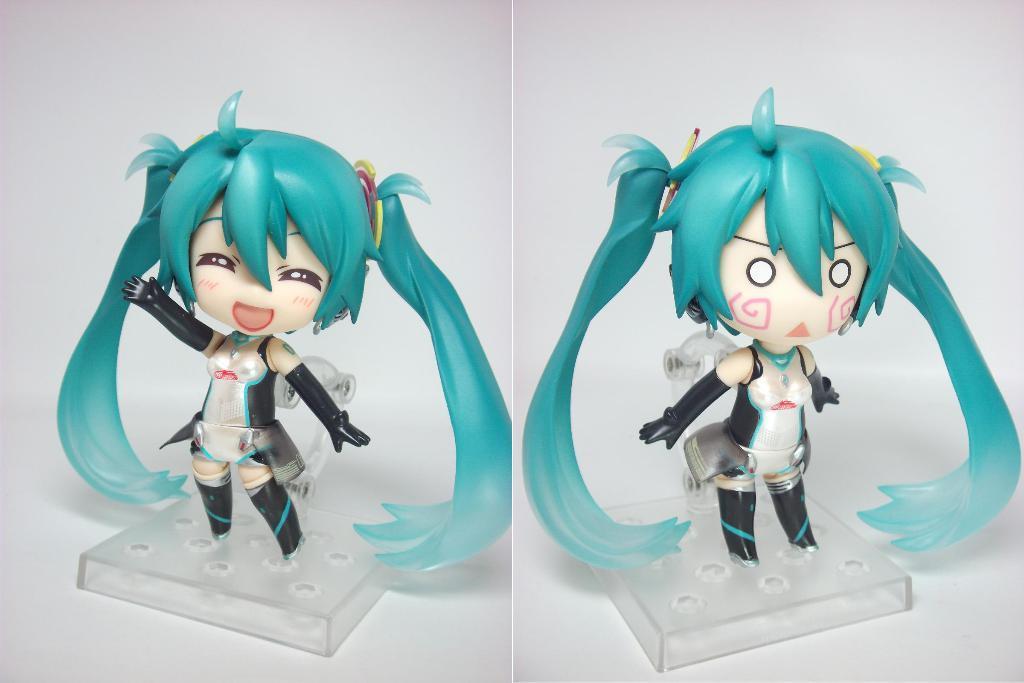Can you describe this image briefly? In this picture I can see a collage image on which I can see toys are placed in the box. 